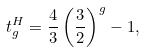<formula> <loc_0><loc_0><loc_500><loc_500>t _ { g } ^ { H } = \frac { 4 } { 3 } \left ( \frac { 3 } { 2 } \right ) ^ { g } - 1 ,</formula> 